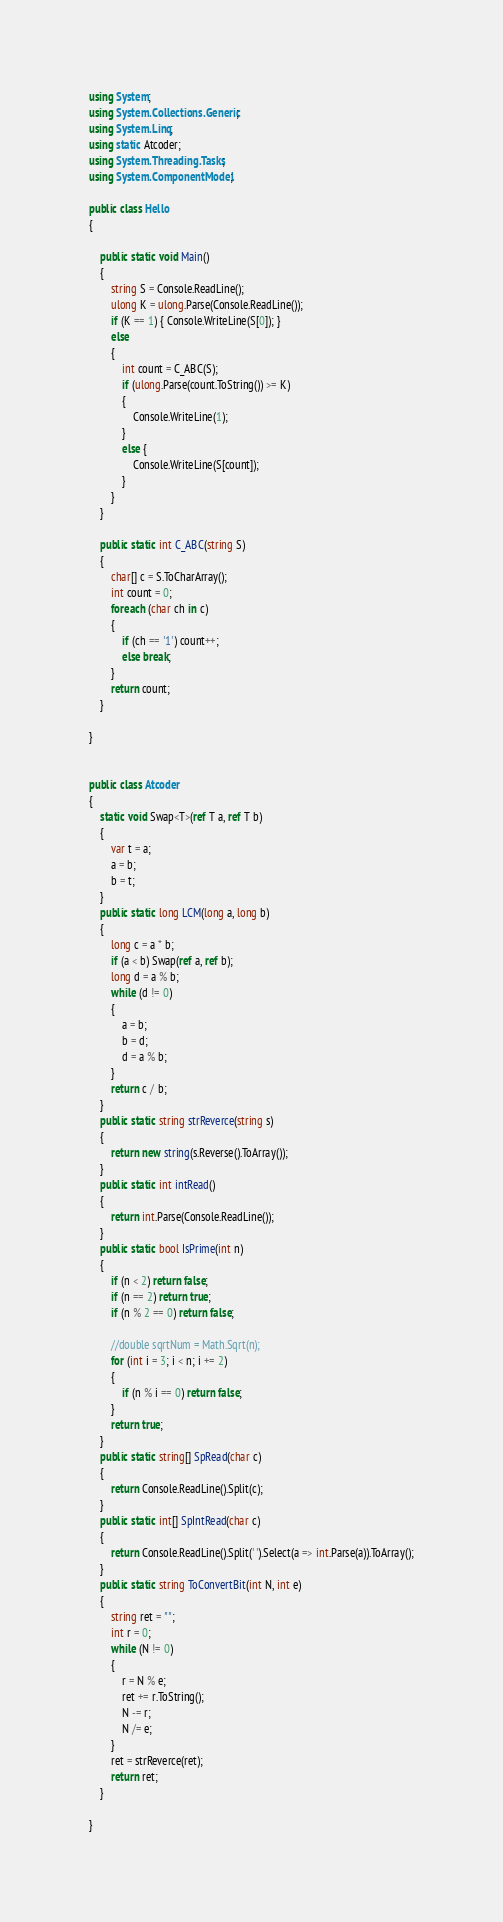<code> <loc_0><loc_0><loc_500><loc_500><_C#_>using System;
using System.Collections.Generic;
using System.Linq;
using static Atcoder;
using System.Threading.Tasks;
using System.ComponentModel;

public class Hello
{

    public static void Main()
    {
        string S = Console.ReadLine();
        ulong K = ulong.Parse(Console.ReadLine());
        if (K == 1) { Console.WriteLine(S[0]); }
        else
        {
            int count = C_ABC(S);
            if (ulong.Parse(count.ToString()) >= K)
            {
                Console.WriteLine(1);
            }
            else {
                Console.WriteLine(S[count]);
            }
        }
    }

    public static int C_ABC(string S)
    {
        char[] c = S.ToCharArray();
        int count = 0;
        foreach (char ch in c)
        {
            if (ch == '1') count++;
            else break;
        }
        return count;
    }

}


public class Atcoder
{
    static void Swap<T>(ref T a, ref T b)
    {
        var t = a;
        a = b;
        b = t;
    }
    public static long LCM(long a, long b)
    {
        long c = a * b;
        if (a < b) Swap(ref a, ref b);
        long d = a % b;
        while (d != 0)
        {
            a = b;
            b = d;
            d = a % b;
        }
        return c / b;
    }
    public static string strReverce(string s)
    {
        return new string(s.Reverse().ToArray());
    }
    public static int intRead()
    {
        return int.Parse(Console.ReadLine());
    }
    public static bool IsPrime(int n)
    {
        if (n < 2) return false;
        if (n == 2) return true;
        if (n % 2 == 0) return false;

        //double sqrtNum = Math.Sqrt(n);
        for (int i = 3; i < n; i += 2)
        {
            if (n % i == 0) return false;
        }
        return true;
    }
    public static string[] SpRead(char c)
    {
        return Console.ReadLine().Split(c);
    }
    public static int[] SpIntRead(char c)
    {
        return Console.ReadLine().Split(' ').Select(a => int.Parse(a)).ToArray();
    }
    public static string ToConvertBit(int N, int e)
    {
        string ret = "";
        int r = 0;
        while (N != 0)
        {
            r = N % e;
            ret += r.ToString();
            N -= r;
            N /= e;
        }
        ret = strReverce(ret);
        return ret;
    }

}
</code> 